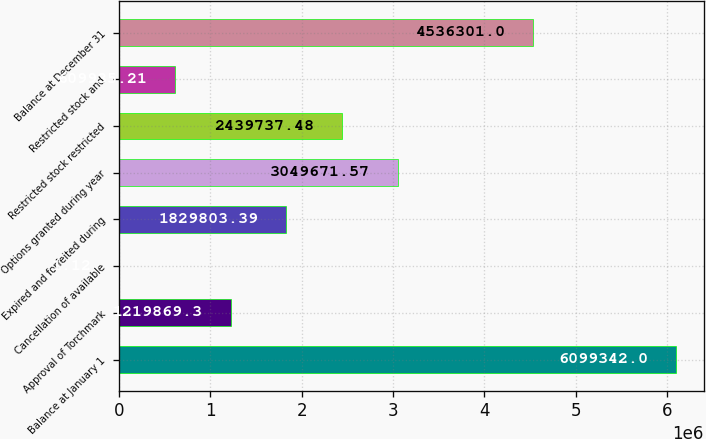Convert chart. <chart><loc_0><loc_0><loc_500><loc_500><bar_chart><fcel>Balance at January 1<fcel>Approval of Torchmark<fcel>Cancellation of available<fcel>Expired and forfeited during<fcel>Options granted during year<fcel>Restricted stock restricted<fcel>Restricted stock and<fcel>Balance at December 31<nl><fcel>6.09934e+06<fcel>1.21987e+06<fcel>1.12<fcel>1.8298e+06<fcel>3.04967e+06<fcel>2.43974e+06<fcel>609935<fcel>4.5363e+06<nl></chart> 